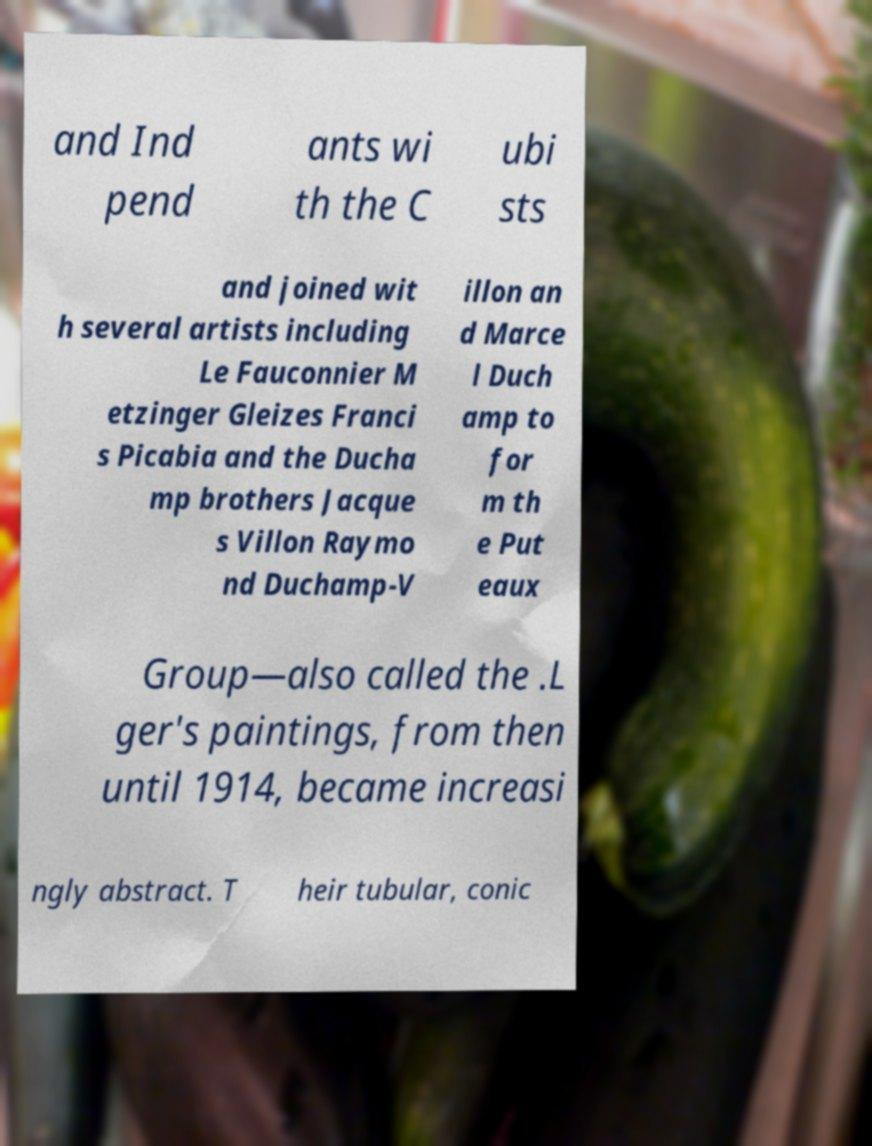Can you read and provide the text displayed in the image?This photo seems to have some interesting text. Can you extract and type it out for me? and Ind pend ants wi th the C ubi sts and joined wit h several artists including Le Fauconnier M etzinger Gleizes Franci s Picabia and the Ducha mp brothers Jacque s Villon Raymo nd Duchamp-V illon an d Marce l Duch amp to for m th e Put eaux Group—also called the .L ger's paintings, from then until 1914, became increasi ngly abstract. T heir tubular, conic 